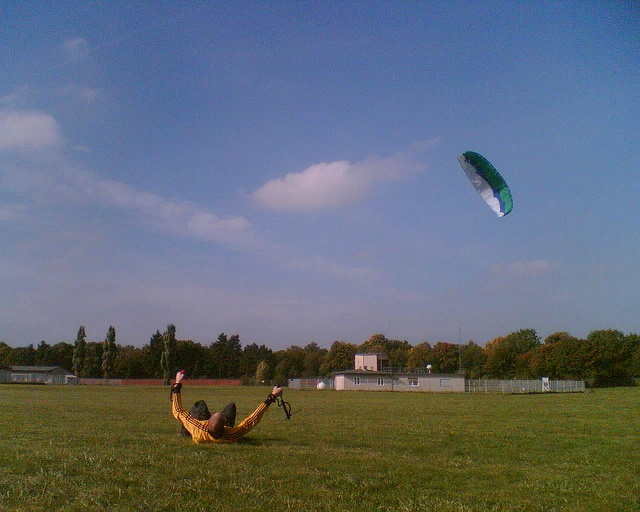Describe the objects in this image and their specific colors. I can see people in gray, black, maroon, olive, and brown tones and kite in gray, black, and teal tones in this image. 